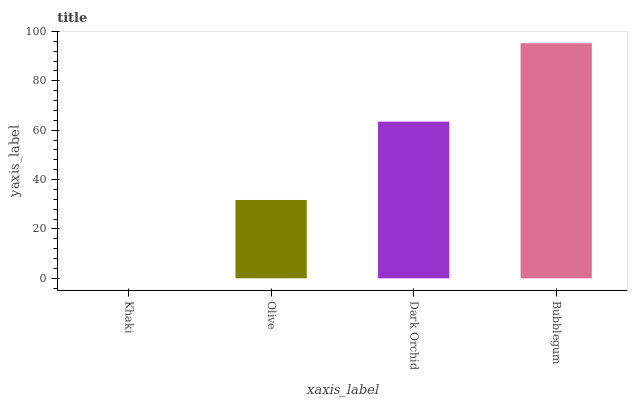Is Khaki the minimum?
Answer yes or no. Yes. Is Bubblegum the maximum?
Answer yes or no. Yes. Is Olive the minimum?
Answer yes or no. No. Is Olive the maximum?
Answer yes or no. No. Is Olive greater than Khaki?
Answer yes or no. Yes. Is Khaki less than Olive?
Answer yes or no. Yes. Is Khaki greater than Olive?
Answer yes or no. No. Is Olive less than Khaki?
Answer yes or no. No. Is Dark Orchid the high median?
Answer yes or no. Yes. Is Olive the low median?
Answer yes or no. Yes. Is Khaki the high median?
Answer yes or no. No. Is Khaki the low median?
Answer yes or no. No. 